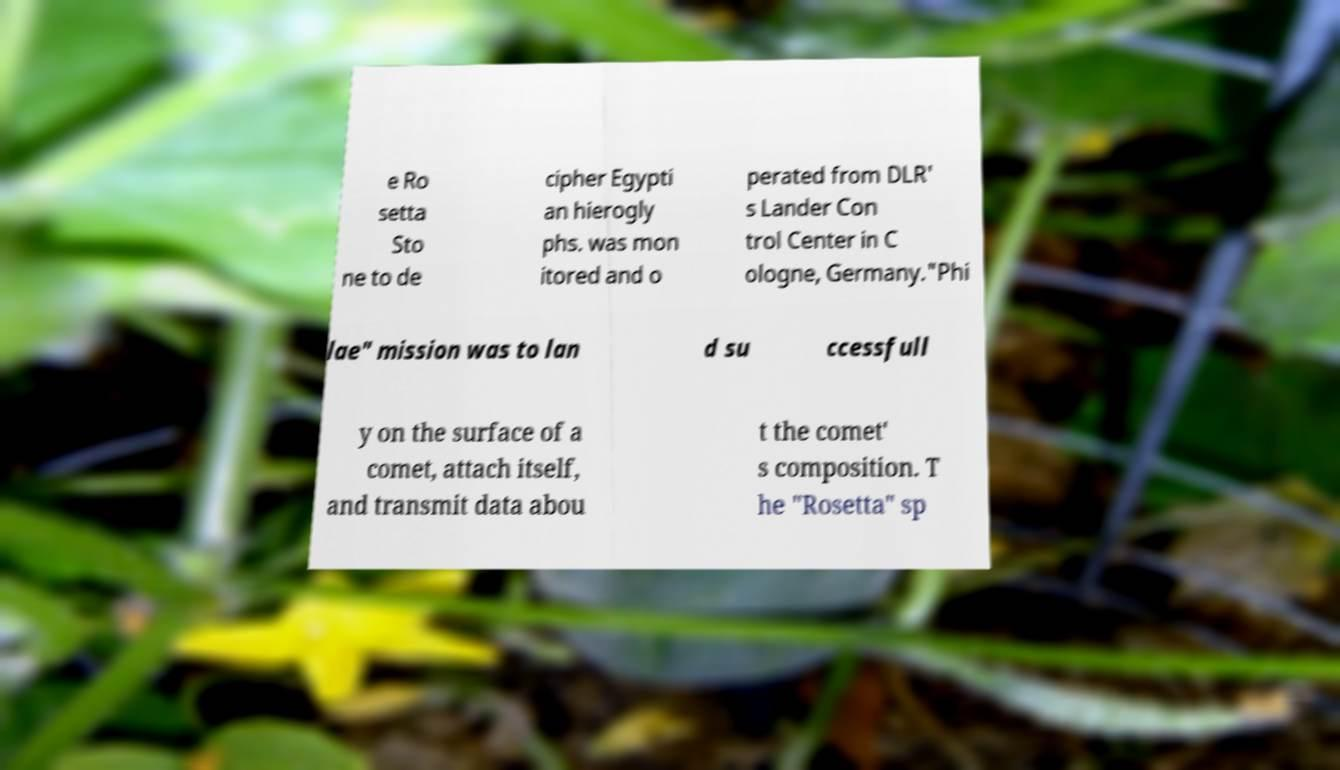Could you extract and type out the text from this image? e Ro setta Sto ne to de cipher Egypti an hierogly phs. was mon itored and o perated from DLR' s Lander Con trol Center in C ologne, Germany."Phi lae" mission was to lan d su ccessfull y on the surface of a comet, attach itself, and transmit data abou t the comet' s composition. T he "Rosetta" sp 